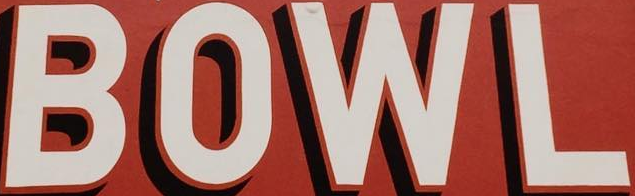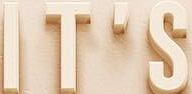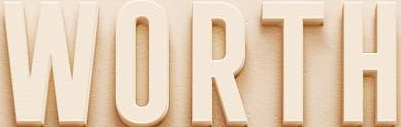What words can you see in these images in sequence, separated by a semicolon? BOWL; IT'S; WORTH 